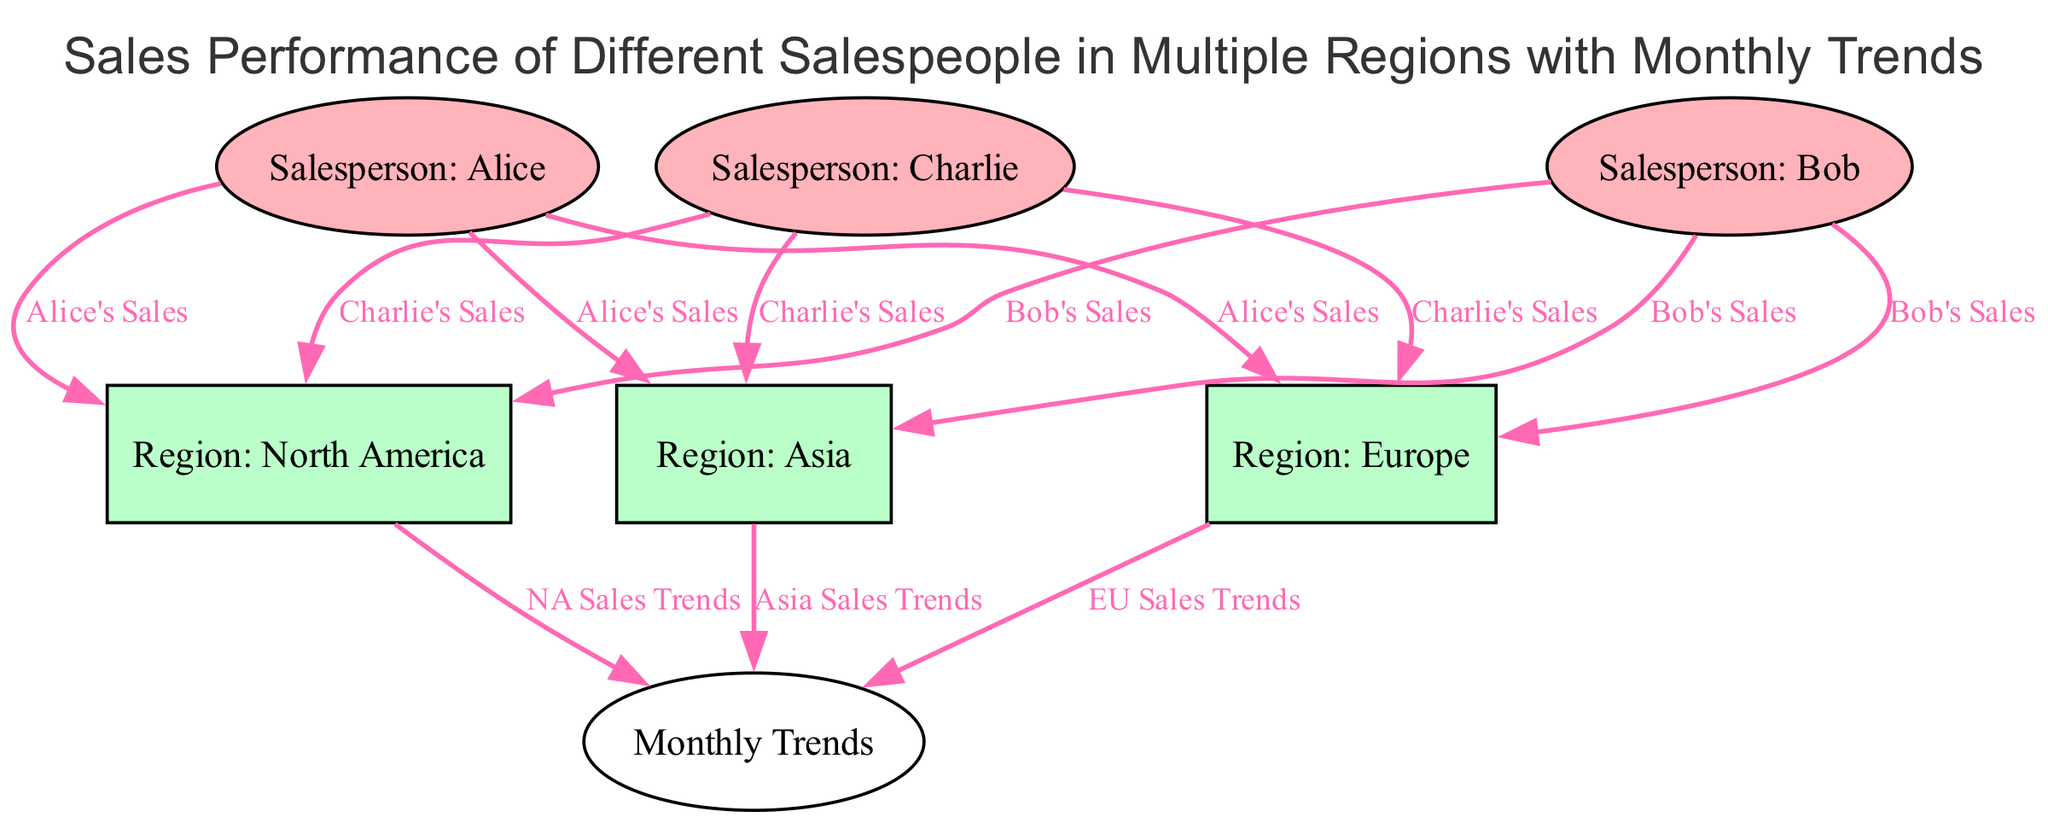What are the names of the salespeople shown in the diagram? The diagram lists three salespeople: Alice, Bob, and Charlie, as indicated in their respective nodes.
Answer: Alice, Bob, Charlie How many regions are represented in the diagram? The diagram includes three distinct regions: North America, Europe, and Asia, as indicated by the nodes labeled accordingly.
Answer: 3 What salesperson has sales linked to the Asia region? The diagram shows links from all three salespeople to the Asia region, specifically indicating sales contributions from Alice, Bob, and Charlie.
Answer: Alice, Bob, Charlie Which region is associated with NA sales trends? The edge pointing from the North America region to the monthly trends indicates that it reflects the sales trends for that specific region, labeled as "NA Sales Trends."
Answer: North America Which salesperson has the most sales connections in the diagram? Each salesperson has three connections, one to each region; thus, all salespeople are equally connected in terms of the number of regions represented.
Answer: Alice, Bob, Charlie What color represents the nodes for salespeople? The diagram shows that salespeople nodes are filled with a light pink color (#FFB3BA).
Answer: Light pink How many edges connect salespeople to regions in total? Each of the three salespeople has connections to three regions, resulting in a total of nine edges (3 salespeople x 3 regions).
Answer: 9 What is the label for the edges connecting regions to monthly trends? The edges connecting the regions to the monthly trends are labeled as "NA Sales Trends," "EU Sales Trends," and "Asia Sales Trends."
Answer: NA Sales Trends, EU Sales Trends, Asia Sales Trends What type of diagram is this? The diagram is a directed graph illustrating the relationships between salespeople, regions, and their sales trends, categorized in a hierarchical structure.
Answer: Directed graph 